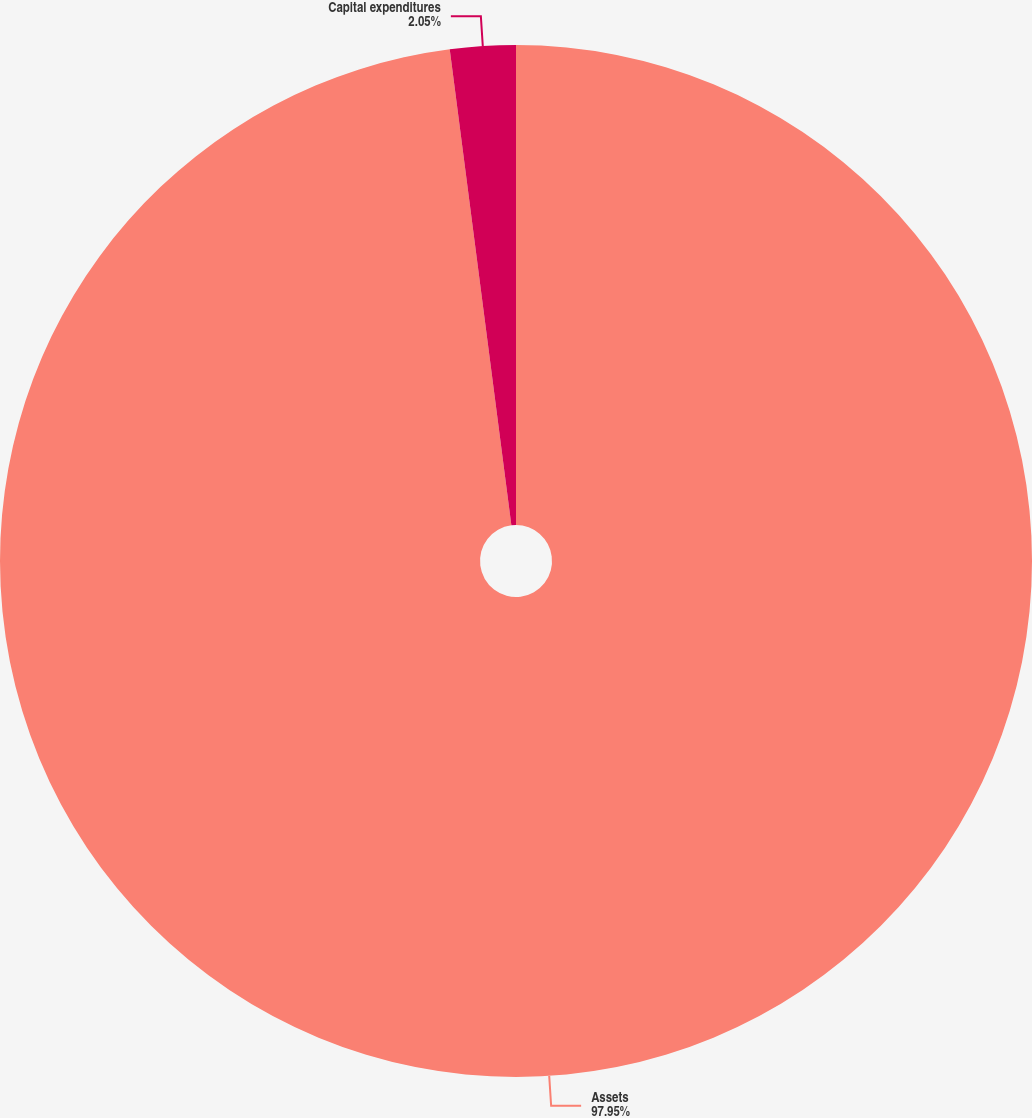Convert chart. <chart><loc_0><loc_0><loc_500><loc_500><pie_chart><fcel>Assets<fcel>Capital expenditures<nl><fcel>97.95%<fcel>2.05%<nl></chart> 